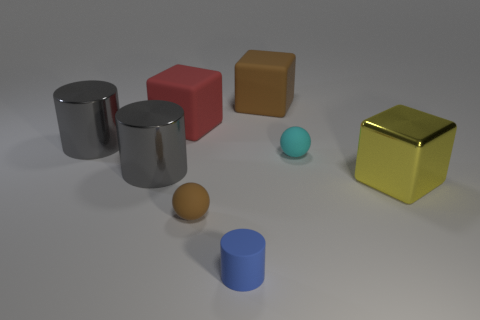Subtract all brown blocks. How many blocks are left? 2 Subtract all gray cylinders. How many cylinders are left? 1 Subtract 3 cylinders. How many cylinders are left? 0 Subtract all brown cubes. Subtract all big brown matte things. How many objects are left? 6 Add 6 yellow objects. How many yellow objects are left? 7 Add 5 brown cubes. How many brown cubes exist? 6 Add 1 tiny brown metal cubes. How many objects exist? 9 Subtract 0 gray spheres. How many objects are left? 8 Subtract all spheres. How many objects are left? 6 Subtract all brown balls. Subtract all purple cylinders. How many balls are left? 1 